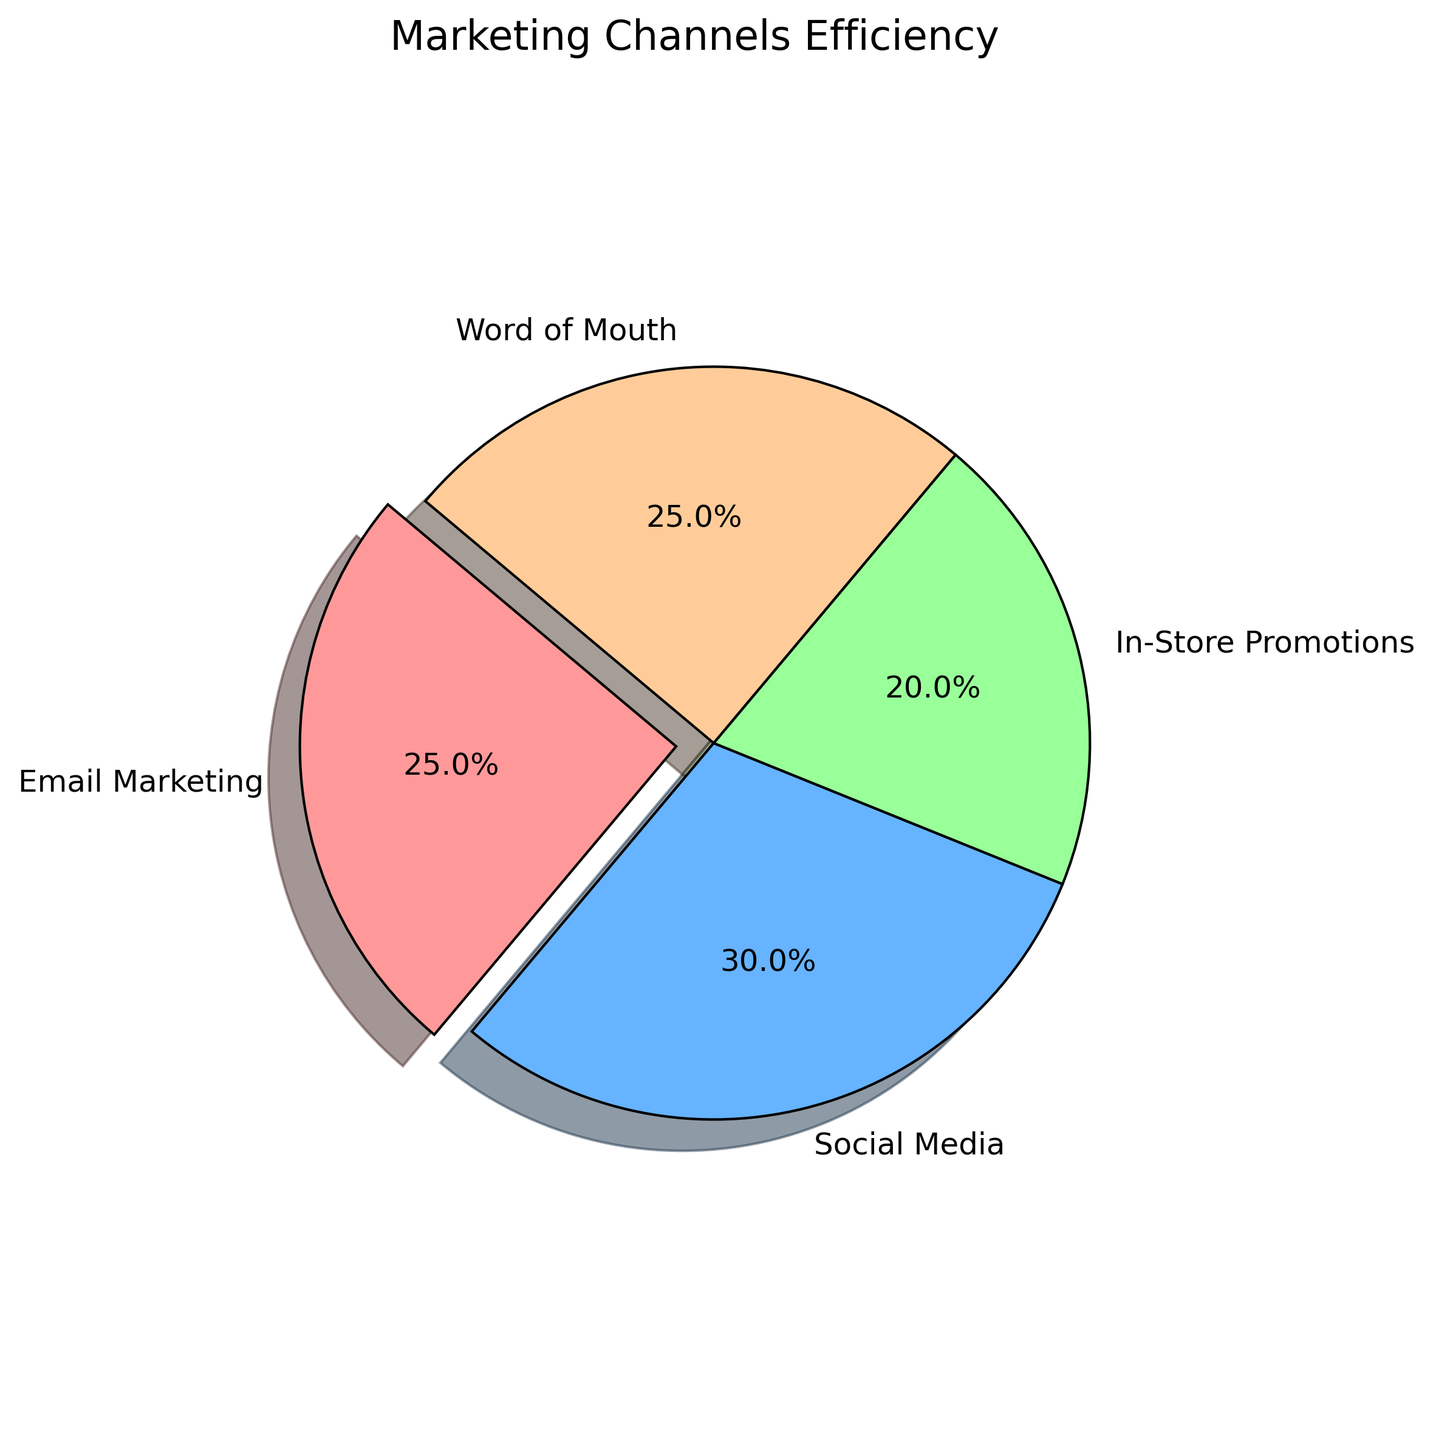What percentage of the total efficiency is contributed by Email Marketing and Word of Mouth combined? Email Marketing contributes 25% and Word of Mouth contributes another 25%. Summing these values gives 25% + 25% = 50%.
Answer: 50% Which marketing channel is the most efficient? Social Media has the highest efficiency at 30%.
Answer: Social Media Which marketing channel is represented by the green color? The green color represents In-Store Promotions.
Answer: In-Store Promotions How much higher is the efficiency of Social Media compared to In-Store Promotions? Social Media has an efficiency of 30%, while In-Store Promotions has 20%. The difference is 30% - 20% = 10%.
Answer: 10% What is the smallest slice in the pie chart? In-Store Promotions is the smallest slice, showing 20% efficiency.
Answer: In-Store Promotions Which marketing channel is highlighted (exploded) in the pie chart? The chart highlights (explodes) the slice for Email Marketing.
Answer: Email Marketing Are there any marketing channels with equal efficiency? If so, which ones? Email Marketing and Word of Mouth both have an efficiency of 25%, making them equal.
Answer: Email Marketing and Word of Mouth What percentage of the total efficiency is not contributed by Social Media? Social Media contributes 30%, so the percentage not contributed is 100% - 30% = 70%.
Answer: 70% How does the efficiency of In-Store Promotions compare to Email Marketing and Word of Mouth? In-Store Promotions has an efficiency of 20%, which is less than both Email Marketing (25%) and Word of Mouth (25%).
Answer: Less than both If Social Media's efficiency improved by 5%, what would be the new total percentage (out of 100%) for that channel? An increase of 5% would make Social Media's efficiency 30% + 5% = 35%.
Answer: 35% 